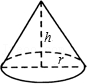Depict what you see in the visual. The image represents a geometric diagram of a cone, which is one of the basic three-dimensional shapes in geometry. The diagram details the cone's circular base with a radius 'r', and vertically from this base to the apex extends the height 'h' of the cone. The lateral surface, which is the curved surface stretching between the base and the apex, helps in calculating the surface area of the cone. This type of diagram is typically used in mathematics to explore concepts related to volume and surface area calculations. 